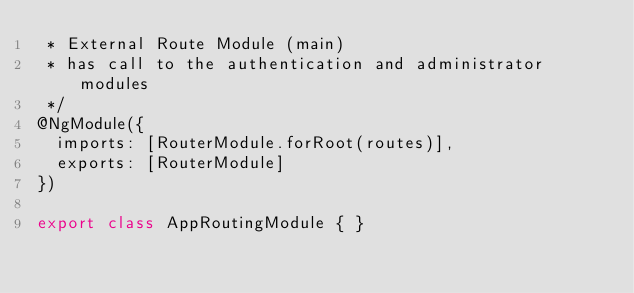Convert code to text. <code><loc_0><loc_0><loc_500><loc_500><_TypeScript_> * External Route Module (main)
 * has call to the authentication and administrator modules
 */
@NgModule({
  imports: [RouterModule.forRoot(routes)],
  exports: [RouterModule]
})

export class AppRoutingModule { }
</code> 